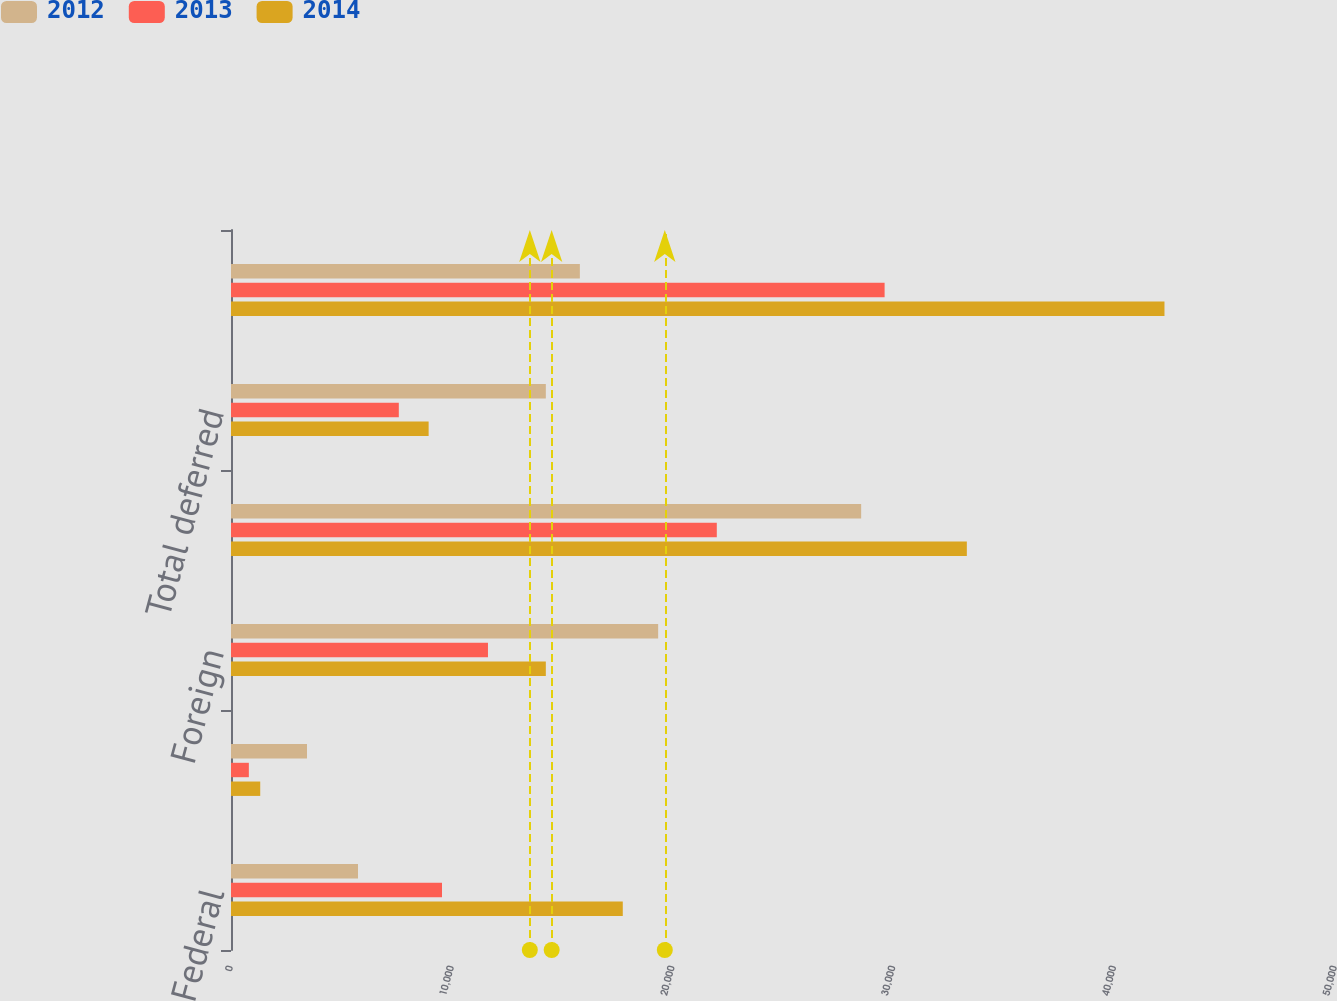<chart> <loc_0><loc_0><loc_500><loc_500><stacked_bar_chart><ecel><fcel>Federal<fcel>State<fcel>Foreign<fcel>Total current<fcel>Total deferred<fcel>Total<nl><fcel>2012<fcel>5752<fcel>3442<fcel>19346<fcel>28540<fcel>14258<fcel>15800<nl><fcel>2013<fcel>9556<fcel>808<fcel>11638<fcel>22002<fcel>7600<fcel>29602<nl><fcel>2014<fcel>17744<fcel>1324<fcel>14258<fcel>33326<fcel>8951<fcel>42277<nl></chart> 